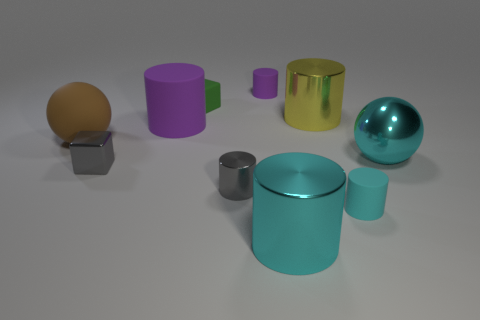There is a large cylinder that is the same color as the metallic ball; what material is it?
Offer a terse response. Metal. How many green things are rubber spheres or large metal blocks?
Your response must be concise. 0. There is a big cyan thing right of the yellow shiny thing; is its shape the same as the large cyan shiny thing that is in front of the tiny shiny block?
Offer a terse response. No. How many other objects are there of the same material as the big brown object?
Offer a very short reply. 4. Is there a sphere in front of the large thing to the left of the shiny object left of the small green thing?
Give a very brief answer. Yes. Are the brown sphere and the gray cube made of the same material?
Provide a succinct answer. No. Is there any other thing that has the same shape as the tiny purple rubber thing?
Provide a succinct answer. Yes. There is a small cylinder on the right side of the tiny rubber cylinder behind the big shiny ball; what is its material?
Provide a short and direct response. Rubber. What size is the yellow object behind the matte ball?
Offer a very short reply. Large. The metal cylinder that is left of the yellow metallic thing and behind the tiny cyan cylinder is what color?
Provide a succinct answer. Gray. 